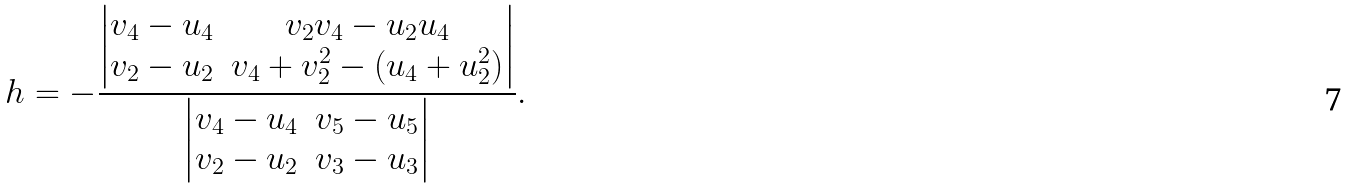<formula> <loc_0><loc_0><loc_500><loc_500>h = - \frac { \begin{vmatrix} v _ { 4 } - u _ { 4 } & v _ { 2 } v _ { 4 } - u _ { 2 } u _ { 4 } \\ v _ { 2 } - u _ { 2 } & v _ { 4 } + v _ { 2 } ^ { 2 } - ( u _ { 4 } + u _ { 2 } ^ { 2 } ) \end{vmatrix} } { \begin{vmatrix} v _ { 4 } - u _ { 4 } & v _ { 5 } - u _ { 5 } \\ v _ { 2 } - u _ { 2 } & v _ { 3 } - u _ { 3 } \end{vmatrix} } .</formula> 